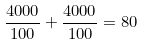Convert formula to latex. <formula><loc_0><loc_0><loc_500><loc_500>\frac { 4 0 0 0 } { 1 0 0 } + \frac { 4 0 0 0 } { 1 0 0 } = 8 0</formula> 